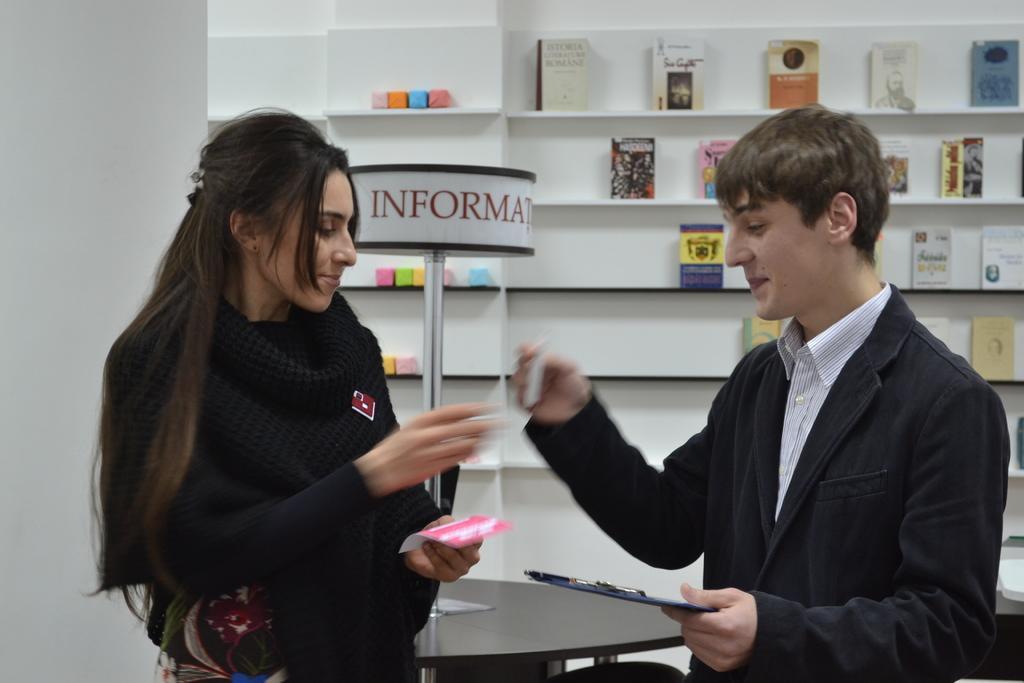Can you describe this image briefly? In this picture I can observe woman and man. Both of them are smiling. Man is wearing a coat. In the background there are some books placed in the shelf. 